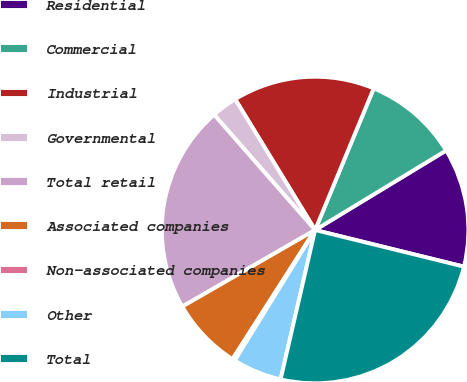Convert chart to OTSL. <chart><loc_0><loc_0><loc_500><loc_500><pie_chart><fcel>Residential<fcel>Commercial<fcel>Industrial<fcel>Governmental<fcel>Total retail<fcel>Associated companies<fcel>Non-associated companies<fcel>Other<fcel>Total<nl><fcel>12.52%<fcel>10.07%<fcel>14.97%<fcel>2.72%<fcel>21.87%<fcel>7.62%<fcel>0.27%<fcel>5.17%<fcel>24.77%<nl></chart> 